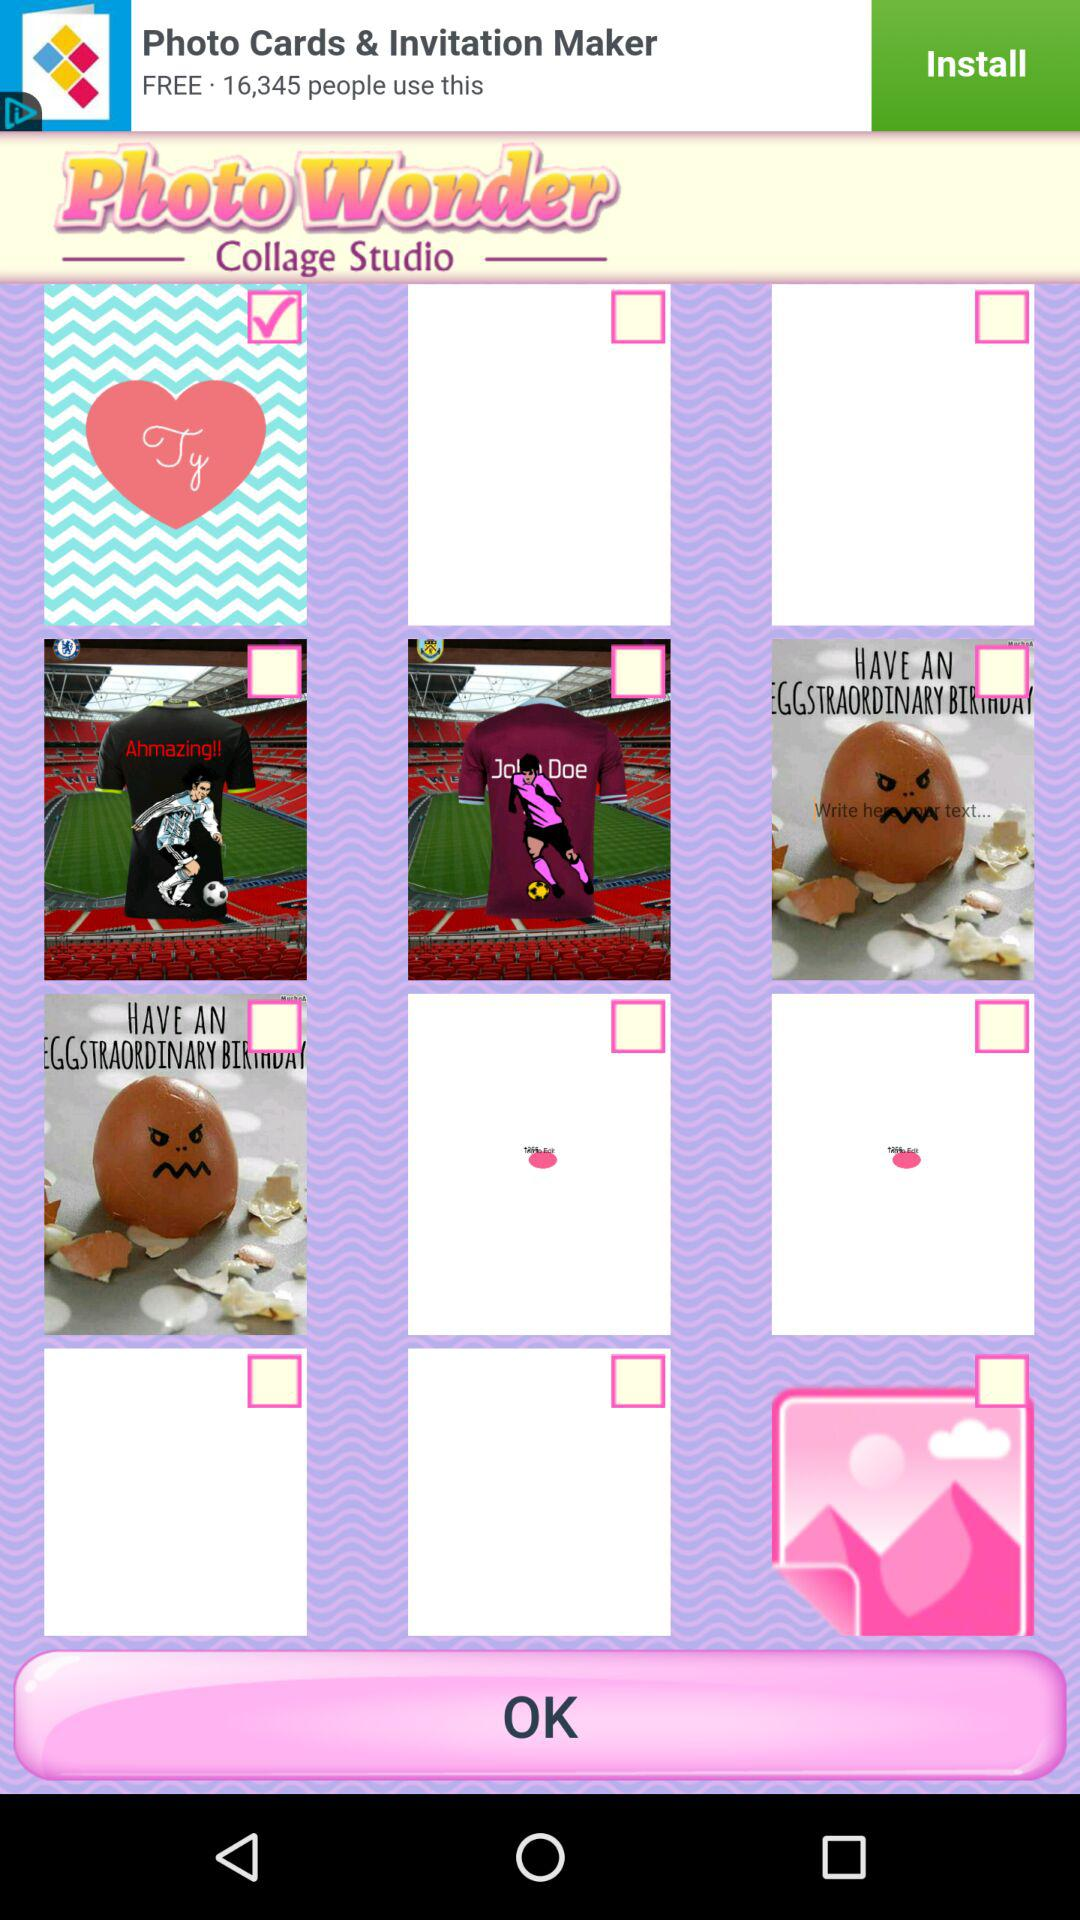How many people have reviewed "PhotoWonder"?
When the provided information is insufficient, respond with <no answer>. <no answer> 